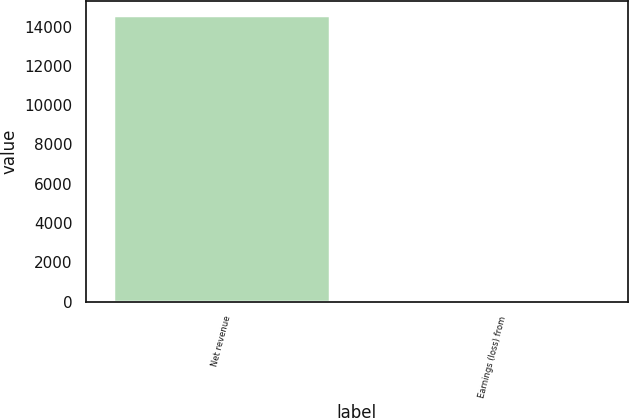Convert chart. <chart><loc_0><loc_0><loc_500><loc_500><bar_chart><fcel>Net revenue<fcel>Earnings (loss) from<nl><fcel>14593<fcel>1<nl></chart> 